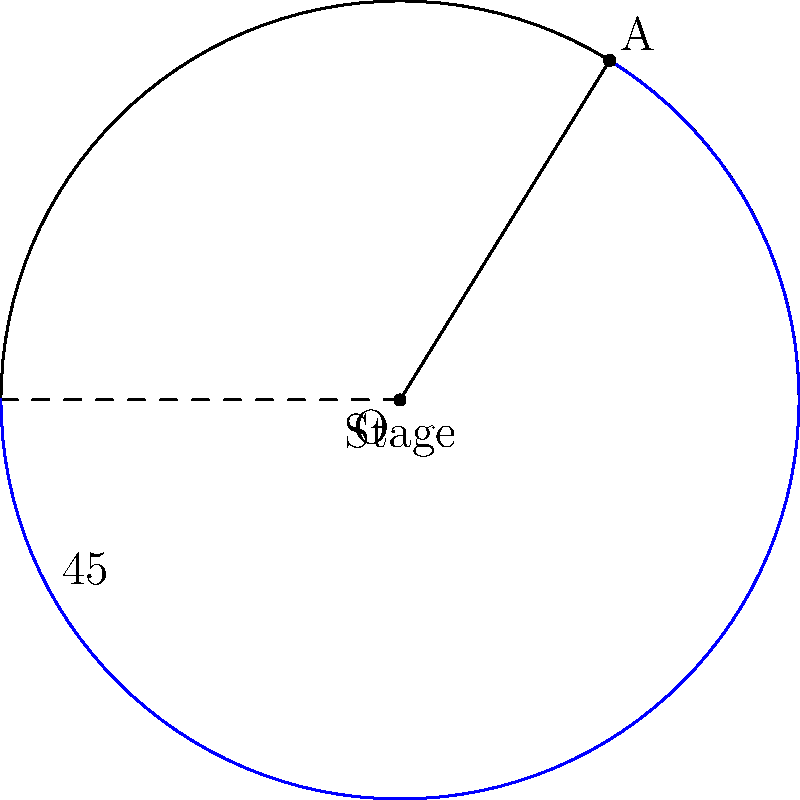As a jazz singer, you're performing on a revolving stage that rotates clockwise. The stage makes a complete revolution in 8 minutes. If you start at the front of the stage and want to face the audience again after 3 minutes, what angle (in degrees) will the stage have rotated through? Use trigonometric principles to determine the answer. Let's approach this step-by-step:

1) First, we need to understand the relationship between time and rotation:
   - A full revolution (360°) takes 8 minutes
   - We want to find the angle after 3 minutes

2) We can set up a proportion:
   $$\frac{360°}{8\text{ minutes}} = \frac{x°}{3\text{ minutes}}$$

3) Cross multiply:
   $$360 \cdot 3 = 8x$$

4) Solve for x:
   $$1080 = 8x$$
   $$x = \frac{1080}{8} = 135$$

5) Therefore, after 3 minutes, the stage will have rotated 135°.

6) To verify using trigonometry:
   - The angular velocity ω = $\frac{360°}{8\text{ minutes}} = 45°/\text{minute}$
   - Angle θ = ω · t = 45°/min · 3 min = 135°

This matches our initial calculation.
Answer: 135° 